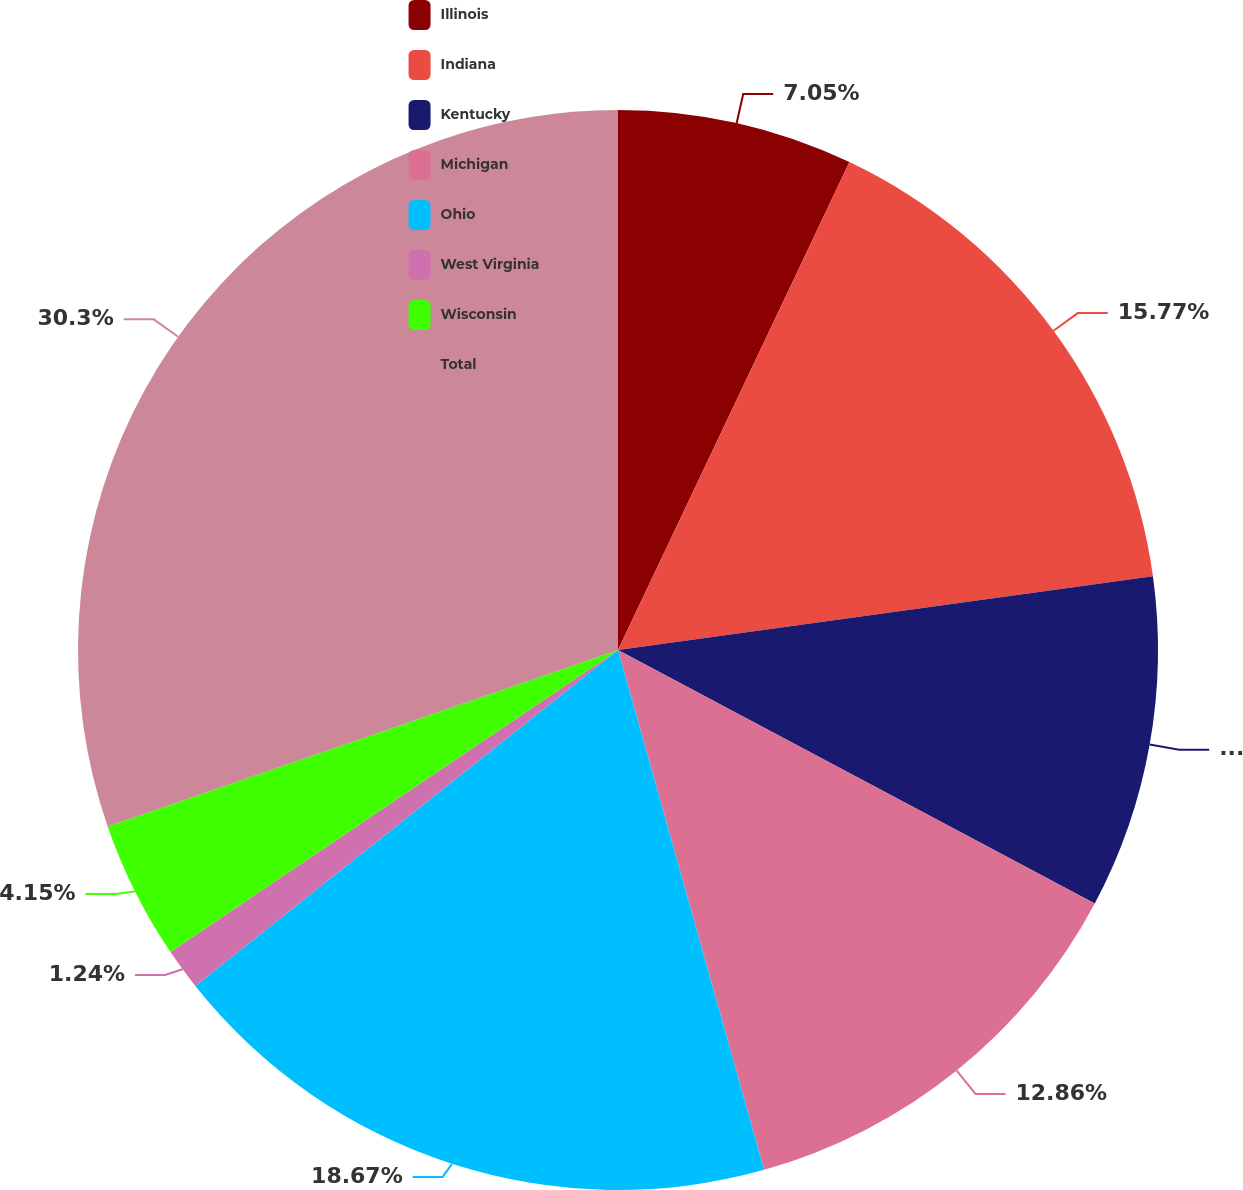Convert chart to OTSL. <chart><loc_0><loc_0><loc_500><loc_500><pie_chart><fcel>Illinois<fcel>Indiana<fcel>Kentucky<fcel>Michigan<fcel>Ohio<fcel>West Virginia<fcel>Wisconsin<fcel>Total<nl><fcel>7.05%<fcel>15.77%<fcel>9.96%<fcel>12.86%<fcel>18.67%<fcel>1.24%<fcel>4.15%<fcel>30.3%<nl></chart> 